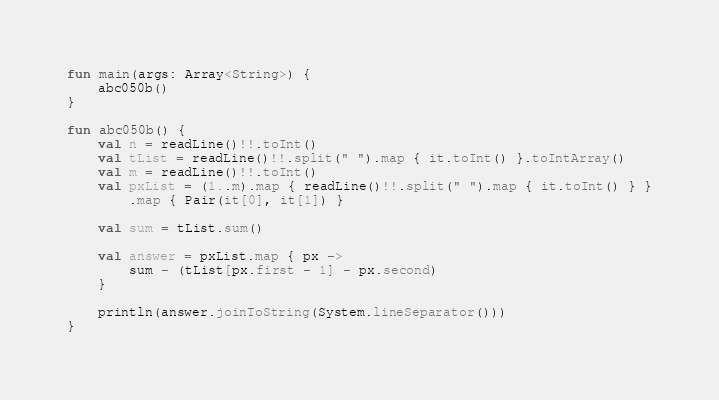Convert code to text. <code><loc_0><loc_0><loc_500><loc_500><_Kotlin_>fun main(args: Array<String>) {
    abc050b()
}

fun abc050b() {
    val n = readLine()!!.toInt()
    val tList = readLine()!!.split(" ").map { it.toInt() }.toIntArray()
    val m = readLine()!!.toInt()
    val pxList = (1..m).map { readLine()!!.split(" ").map { it.toInt() } }
        .map { Pair(it[0], it[1]) }

    val sum = tList.sum()

    val answer = pxList.map { px ->
        sum - (tList[px.first - 1] - px.second)
    }

    println(answer.joinToString(System.lineSeparator()))
}
</code> 